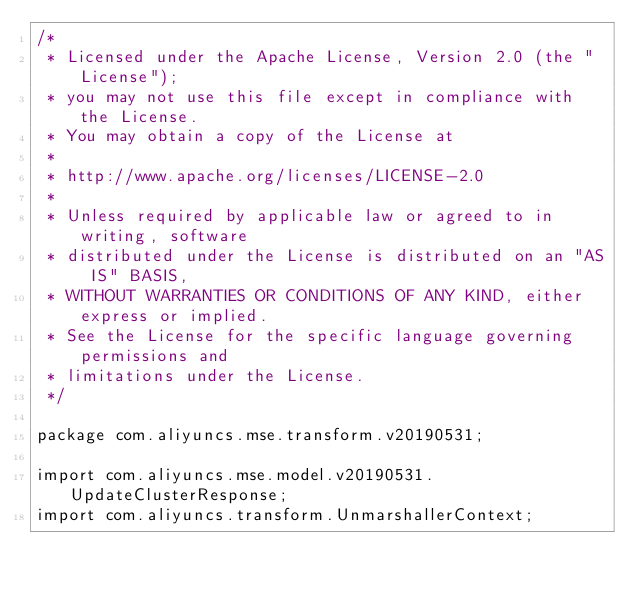Convert code to text. <code><loc_0><loc_0><loc_500><loc_500><_Java_>/*
 * Licensed under the Apache License, Version 2.0 (the "License");
 * you may not use this file except in compliance with the License.
 * You may obtain a copy of the License at
 *
 * http://www.apache.org/licenses/LICENSE-2.0
 *
 * Unless required by applicable law or agreed to in writing, software
 * distributed under the License is distributed on an "AS IS" BASIS,
 * WITHOUT WARRANTIES OR CONDITIONS OF ANY KIND, either express or implied.
 * See the License for the specific language governing permissions and
 * limitations under the License.
 */

package com.aliyuncs.mse.transform.v20190531;

import com.aliyuncs.mse.model.v20190531.UpdateClusterResponse;
import com.aliyuncs.transform.UnmarshallerContext;

</code> 